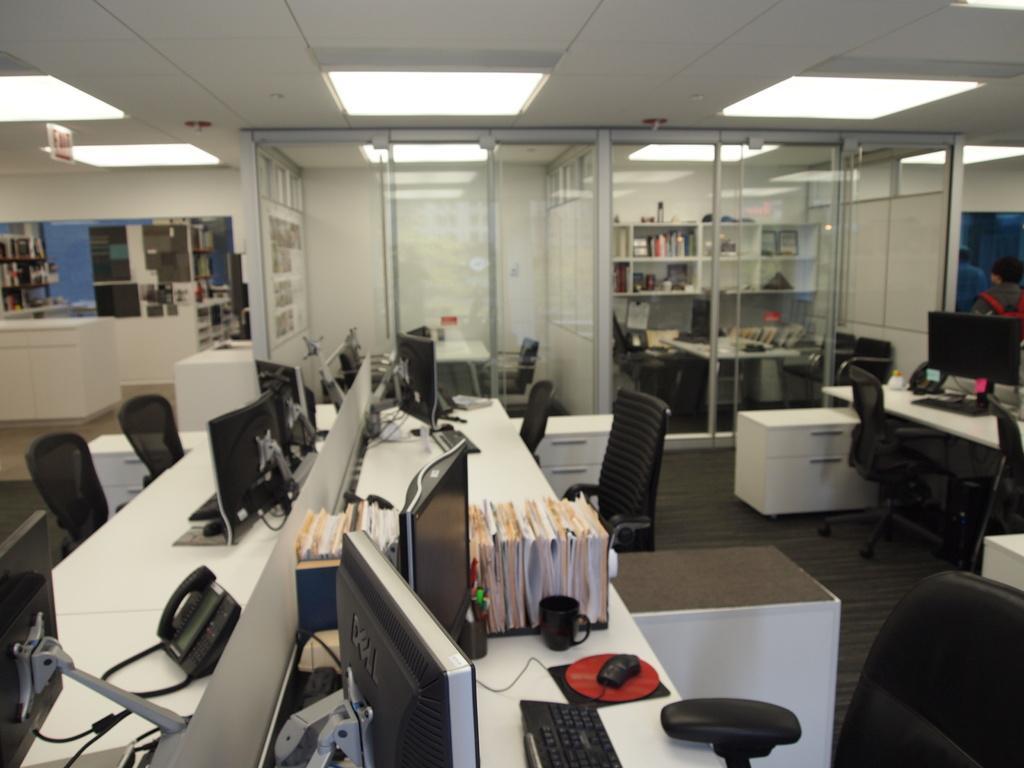Please provide a concise description of this image. In this image there is a table towards the bottom of the image, there are objects on the table, there are chairs, there are monitors, there is a shelf, there are objects in the shelf, there is a wall, there is a board towards the left of the image, there is text on the board, there is a person towards the right of the image, the person is wearing a bag, there is a roof towards the top of the image, there are lights. 